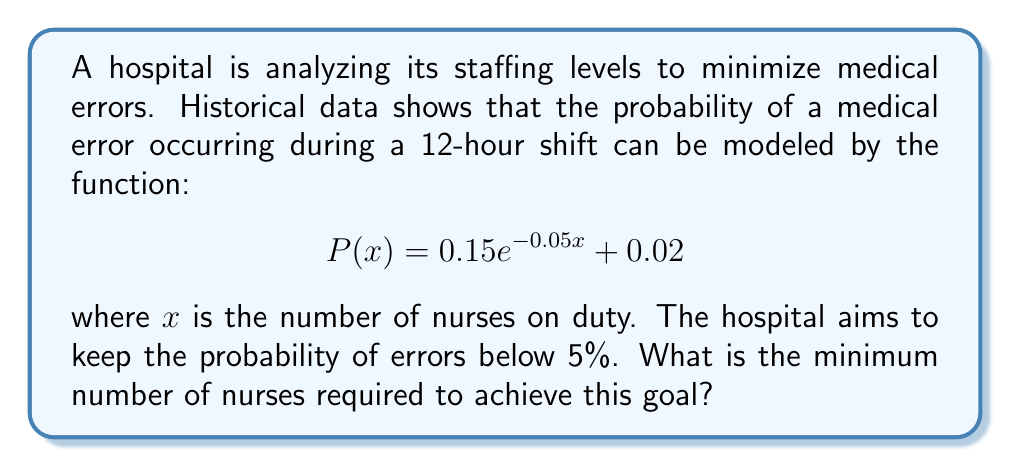Teach me how to tackle this problem. To solve this problem, we need to follow these steps:

1) We want to find $x$ such that $P(x) < 0.05$

2) Set up the inequality:
   $$0.15e^{-0.05x} + 0.02 < 0.05$$

3) Subtract 0.02 from both sides:
   $$0.15e^{-0.05x} < 0.03$$

4) Divide both sides by 0.15:
   $$e^{-0.05x} < 0.2$$

5) Take the natural logarithm of both sides:
   $$-0.05x < \ln(0.2)$$

6) Divide both sides by -0.05:
   $$x > -\frac{\ln(0.2)}{0.05}$$

7) Calculate the right-hand side:
   $$x > 32.19$$

8) Since $x$ represents the number of nurses, it must be a whole number. Therefore, we need to round up to the next integer.
Answer: 33 nurses 